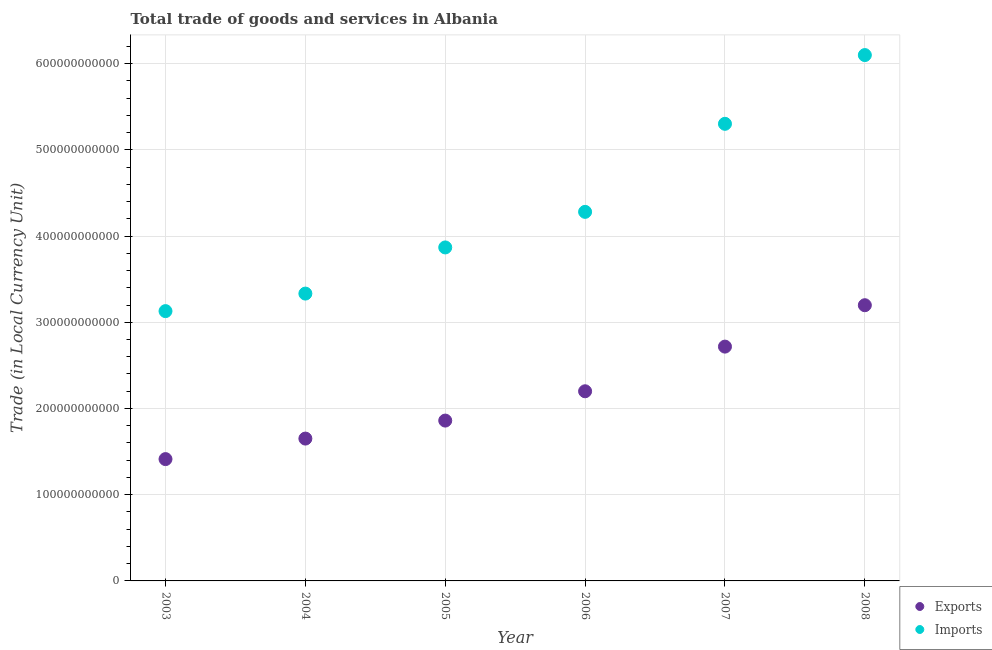How many different coloured dotlines are there?
Ensure brevity in your answer.  2. What is the imports of goods and services in 2004?
Keep it short and to the point. 3.33e+11. Across all years, what is the maximum export of goods and services?
Give a very brief answer. 3.20e+11. Across all years, what is the minimum imports of goods and services?
Keep it short and to the point. 3.13e+11. What is the total imports of goods and services in the graph?
Give a very brief answer. 2.60e+12. What is the difference between the export of goods and services in 2004 and that in 2008?
Make the answer very short. -1.55e+11. What is the difference between the imports of goods and services in 2006 and the export of goods and services in 2004?
Ensure brevity in your answer.  2.63e+11. What is the average imports of goods and services per year?
Give a very brief answer. 4.34e+11. In the year 2003, what is the difference between the export of goods and services and imports of goods and services?
Make the answer very short. -1.72e+11. In how many years, is the export of goods and services greater than 240000000000 LCU?
Ensure brevity in your answer.  2. What is the ratio of the export of goods and services in 2005 to that in 2006?
Make the answer very short. 0.85. What is the difference between the highest and the second highest imports of goods and services?
Your answer should be compact. 7.97e+1. What is the difference between the highest and the lowest export of goods and services?
Make the answer very short. 1.78e+11. How many dotlines are there?
Give a very brief answer. 2. How many years are there in the graph?
Your response must be concise. 6. What is the difference between two consecutive major ticks on the Y-axis?
Keep it short and to the point. 1.00e+11. Does the graph contain grids?
Keep it short and to the point. Yes. Where does the legend appear in the graph?
Offer a terse response. Bottom right. What is the title of the graph?
Your answer should be very brief. Total trade of goods and services in Albania. Does "Malaria" appear as one of the legend labels in the graph?
Give a very brief answer. No. What is the label or title of the X-axis?
Ensure brevity in your answer.  Year. What is the label or title of the Y-axis?
Provide a short and direct response. Trade (in Local Currency Unit). What is the Trade (in Local Currency Unit) in Exports in 2003?
Provide a short and direct response. 1.41e+11. What is the Trade (in Local Currency Unit) in Imports in 2003?
Provide a succinct answer. 3.13e+11. What is the Trade (in Local Currency Unit) of Exports in 2004?
Your response must be concise. 1.65e+11. What is the Trade (in Local Currency Unit) in Imports in 2004?
Provide a succinct answer. 3.33e+11. What is the Trade (in Local Currency Unit) of Exports in 2005?
Give a very brief answer. 1.86e+11. What is the Trade (in Local Currency Unit) of Imports in 2005?
Offer a terse response. 3.87e+11. What is the Trade (in Local Currency Unit) in Exports in 2006?
Offer a very short reply. 2.20e+11. What is the Trade (in Local Currency Unit) of Imports in 2006?
Keep it short and to the point. 4.28e+11. What is the Trade (in Local Currency Unit) in Exports in 2007?
Ensure brevity in your answer.  2.72e+11. What is the Trade (in Local Currency Unit) in Imports in 2007?
Offer a very short reply. 5.30e+11. What is the Trade (in Local Currency Unit) in Exports in 2008?
Your answer should be very brief. 3.20e+11. What is the Trade (in Local Currency Unit) in Imports in 2008?
Provide a short and direct response. 6.10e+11. Across all years, what is the maximum Trade (in Local Currency Unit) in Exports?
Your answer should be compact. 3.20e+11. Across all years, what is the maximum Trade (in Local Currency Unit) of Imports?
Your response must be concise. 6.10e+11. Across all years, what is the minimum Trade (in Local Currency Unit) in Exports?
Provide a short and direct response. 1.41e+11. Across all years, what is the minimum Trade (in Local Currency Unit) of Imports?
Your response must be concise. 3.13e+11. What is the total Trade (in Local Currency Unit) of Exports in the graph?
Provide a short and direct response. 1.30e+12. What is the total Trade (in Local Currency Unit) in Imports in the graph?
Offer a terse response. 2.60e+12. What is the difference between the Trade (in Local Currency Unit) in Exports in 2003 and that in 2004?
Your response must be concise. -2.38e+1. What is the difference between the Trade (in Local Currency Unit) in Imports in 2003 and that in 2004?
Your answer should be compact. -2.03e+1. What is the difference between the Trade (in Local Currency Unit) of Exports in 2003 and that in 2005?
Ensure brevity in your answer.  -4.47e+1. What is the difference between the Trade (in Local Currency Unit) of Imports in 2003 and that in 2005?
Offer a terse response. -7.39e+1. What is the difference between the Trade (in Local Currency Unit) in Exports in 2003 and that in 2006?
Your response must be concise. -7.87e+1. What is the difference between the Trade (in Local Currency Unit) of Imports in 2003 and that in 2006?
Make the answer very short. -1.15e+11. What is the difference between the Trade (in Local Currency Unit) in Exports in 2003 and that in 2007?
Give a very brief answer. -1.30e+11. What is the difference between the Trade (in Local Currency Unit) of Imports in 2003 and that in 2007?
Keep it short and to the point. -2.17e+11. What is the difference between the Trade (in Local Currency Unit) in Exports in 2003 and that in 2008?
Ensure brevity in your answer.  -1.78e+11. What is the difference between the Trade (in Local Currency Unit) of Imports in 2003 and that in 2008?
Provide a short and direct response. -2.97e+11. What is the difference between the Trade (in Local Currency Unit) of Exports in 2004 and that in 2005?
Your answer should be compact. -2.09e+1. What is the difference between the Trade (in Local Currency Unit) of Imports in 2004 and that in 2005?
Your answer should be very brief. -5.35e+1. What is the difference between the Trade (in Local Currency Unit) of Exports in 2004 and that in 2006?
Make the answer very short. -5.49e+1. What is the difference between the Trade (in Local Currency Unit) in Imports in 2004 and that in 2006?
Make the answer very short. -9.48e+1. What is the difference between the Trade (in Local Currency Unit) in Exports in 2004 and that in 2007?
Give a very brief answer. -1.07e+11. What is the difference between the Trade (in Local Currency Unit) of Imports in 2004 and that in 2007?
Make the answer very short. -1.97e+11. What is the difference between the Trade (in Local Currency Unit) in Exports in 2004 and that in 2008?
Provide a succinct answer. -1.55e+11. What is the difference between the Trade (in Local Currency Unit) of Imports in 2004 and that in 2008?
Keep it short and to the point. -2.77e+11. What is the difference between the Trade (in Local Currency Unit) in Exports in 2005 and that in 2006?
Give a very brief answer. -3.40e+1. What is the difference between the Trade (in Local Currency Unit) in Imports in 2005 and that in 2006?
Give a very brief answer. -4.13e+1. What is the difference between the Trade (in Local Currency Unit) in Exports in 2005 and that in 2007?
Your response must be concise. -8.58e+1. What is the difference between the Trade (in Local Currency Unit) in Imports in 2005 and that in 2007?
Keep it short and to the point. -1.43e+11. What is the difference between the Trade (in Local Currency Unit) in Exports in 2005 and that in 2008?
Your answer should be very brief. -1.34e+11. What is the difference between the Trade (in Local Currency Unit) in Imports in 2005 and that in 2008?
Make the answer very short. -2.23e+11. What is the difference between the Trade (in Local Currency Unit) of Exports in 2006 and that in 2007?
Offer a terse response. -5.18e+1. What is the difference between the Trade (in Local Currency Unit) in Imports in 2006 and that in 2007?
Provide a short and direct response. -1.02e+11. What is the difference between the Trade (in Local Currency Unit) in Exports in 2006 and that in 2008?
Ensure brevity in your answer.  -9.98e+1. What is the difference between the Trade (in Local Currency Unit) in Imports in 2006 and that in 2008?
Ensure brevity in your answer.  -1.82e+11. What is the difference between the Trade (in Local Currency Unit) in Exports in 2007 and that in 2008?
Provide a succinct answer. -4.80e+1. What is the difference between the Trade (in Local Currency Unit) of Imports in 2007 and that in 2008?
Make the answer very short. -7.97e+1. What is the difference between the Trade (in Local Currency Unit) of Exports in 2003 and the Trade (in Local Currency Unit) of Imports in 2004?
Make the answer very short. -1.92e+11. What is the difference between the Trade (in Local Currency Unit) in Exports in 2003 and the Trade (in Local Currency Unit) in Imports in 2005?
Make the answer very short. -2.46e+11. What is the difference between the Trade (in Local Currency Unit) of Exports in 2003 and the Trade (in Local Currency Unit) of Imports in 2006?
Provide a short and direct response. -2.87e+11. What is the difference between the Trade (in Local Currency Unit) in Exports in 2003 and the Trade (in Local Currency Unit) in Imports in 2007?
Keep it short and to the point. -3.89e+11. What is the difference between the Trade (in Local Currency Unit) of Exports in 2003 and the Trade (in Local Currency Unit) of Imports in 2008?
Make the answer very short. -4.69e+11. What is the difference between the Trade (in Local Currency Unit) in Exports in 2004 and the Trade (in Local Currency Unit) in Imports in 2005?
Give a very brief answer. -2.22e+11. What is the difference between the Trade (in Local Currency Unit) of Exports in 2004 and the Trade (in Local Currency Unit) of Imports in 2006?
Ensure brevity in your answer.  -2.63e+11. What is the difference between the Trade (in Local Currency Unit) of Exports in 2004 and the Trade (in Local Currency Unit) of Imports in 2007?
Your answer should be very brief. -3.65e+11. What is the difference between the Trade (in Local Currency Unit) of Exports in 2004 and the Trade (in Local Currency Unit) of Imports in 2008?
Your response must be concise. -4.45e+11. What is the difference between the Trade (in Local Currency Unit) of Exports in 2005 and the Trade (in Local Currency Unit) of Imports in 2006?
Your answer should be very brief. -2.42e+11. What is the difference between the Trade (in Local Currency Unit) in Exports in 2005 and the Trade (in Local Currency Unit) in Imports in 2007?
Make the answer very short. -3.44e+11. What is the difference between the Trade (in Local Currency Unit) of Exports in 2005 and the Trade (in Local Currency Unit) of Imports in 2008?
Offer a very short reply. -4.24e+11. What is the difference between the Trade (in Local Currency Unit) in Exports in 2006 and the Trade (in Local Currency Unit) in Imports in 2007?
Your answer should be compact. -3.10e+11. What is the difference between the Trade (in Local Currency Unit) of Exports in 2006 and the Trade (in Local Currency Unit) of Imports in 2008?
Offer a terse response. -3.90e+11. What is the difference between the Trade (in Local Currency Unit) in Exports in 2007 and the Trade (in Local Currency Unit) in Imports in 2008?
Your answer should be very brief. -3.38e+11. What is the average Trade (in Local Currency Unit) of Exports per year?
Provide a short and direct response. 2.17e+11. What is the average Trade (in Local Currency Unit) of Imports per year?
Offer a terse response. 4.34e+11. In the year 2003, what is the difference between the Trade (in Local Currency Unit) of Exports and Trade (in Local Currency Unit) of Imports?
Keep it short and to the point. -1.72e+11. In the year 2004, what is the difference between the Trade (in Local Currency Unit) of Exports and Trade (in Local Currency Unit) of Imports?
Ensure brevity in your answer.  -1.68e+11. In the year 2005, what is the difference between the Trade (in Local Currency Unit) in Exports and Trade (in Local Currency Unit) in Imports?
Provide a short and direct response. -2.01e+11. In the year 2006, what is the difference between the Trade (in Local Currency Unit) in Exports and Trade (in Local Currency Unit) in Imports?
Provide a succinct answer. -2.08e+11. In the year 2007, what is the difference between the Trade (in Local Currency Unit) of Exports and Trade (in Local Currency Unit) of Imports?
Make the answer very short. -2.58e+11. In the year 2008, what is the difference between the Trade (in Local Currency Unit) of Exports and Trade (in Local Currency Unit) of Imports?
Offer a terse response. -2.90e+11. What is the ratio of the Trade (in Local Currency Unit) of Exports in 2003 to that in 2004?
Keep it short and to the point. 0.86. What is the ratio of the Trade (in Local Currency Unit) in Imports in 2003 to that in 2004?
Your answer should be compact. 0.94. What is the ratio of the Trade (in Local Currency Unit) of Exports in 2003 to that in 2005?
Provide a succinct answer. 0.76. What is the ratio of the Trade (in Local Currency Unit) in Imports in 2003 to that in 2005?
Provide a short and direct response. 0.81. What is the ratio of the Trade (in Local Currency Unit) in Exports in 2003 to that in 2006?
Offer a terse response. 0.64. What is the ratio of the Trade (in Local Currency Unit) of Imports in 2003 to that in 2006?
Keep it short and to the point. 0.73. What is the ratio of the Trade (in Local Currency Unit) in Exports in 2003 to that in 2007?
Offer a terse response. 0.52. What is the ratio of the Trade (in Local Currency Unit) in Imports in 2003 to that in 2007?
Your answer should be very brief. 0.59. What is the ratio of the Trade (in Local Currency Unit) in Exports in 2003 to that in 2008?
Offer a very short reply. 0.44. What is the ratio of the Trade (in Local Currency Unit) of Imports in 2003 to that in 2008?
Your response must be concise. 0.51. What is the ratio of the Trade (in Local Currency Unit) in Exports in 2004 to that in 2005?
Make the answer very short. 0.89. What is the ratio of the Trade (in Local Currency Unit) of Imports in 2004 to that in 2005?
Provide a succinct answer. 0.86. What is the ratio of the Trade (in Local Currency Unit) in Exports in 2004 to that in 2006?
Offer a terse response. 0.75. What is the ratio of the Trade (in Local Currency Unit) of Imports in 2004 to that in 2006?
Your answer should be compact. 0.78. What is the ratio of the Trade (in Local Currency Unit) in Exports in 2004 to that in 2007?
Your response must be concise. 0.61. What is the ratio of the Trade (in Local Currency Unit) of Imports in 2004 to that in 2007?
Your answer should be very brief. 0.63. What is the ratio of the Trade (in Local Currency Unit) of Exports in 2004 to that in 2008?
Offer a terse response. 0.52. What is the ratio of the Trade (in Local Currency Unit) of Imports in 2004 to that in 2008?
Give a very brief answer. 0.55. What is the ratio of the Trade (in Local Currency Unit) of Exports in 2005 to that in 2006?
Your answer should be very brief. 0.85. What is the ratio of the Trade (in Local Currency Unit) of Imports in 2005 to that in 2006?
Provide a short and direct response. 0.9. What is the ratio of the Trade (in Local Currency Unit) of Exports in 2005 to that in 2007?
Offer a terse response. 0.68. What is the ratio of the Trade (in Local Currency Unit) of Imports in 2005 to that in 2007?
Your answer should be compact. 0.73. What is the ratio of the Trade (in Local Currency Unit) of Exports in 2005 to that in 2008?
Your answer should be compact. 0.58. What is the ratio of the Trade (in Local Currency Unit) in Imports in 2005 to that in 2008?
Your answer should be compact. 0.63. What is the ratio of the Trade (in Local Currency Unit) in Exports in 2006 to that in 2007?
Offer a very short reply. 0.81. What is the ratio of the Trade (in Local Currency Unit) of Imports in 2006 to that in 2007?
Offer a terse response. 0.81. What is the ratio of the Trade (in Local Currency Unit) in Exports in 2006 to that in 2008?
Ensure brevity in your answer.  0.69. What is the ratio of the Trade (in Local Currency Unit) in Imports in 2006 to that in 2008?
Your answer should be compact. 0.7. What is the ratio of the Trade (in Local Currency Unit) of Exports in 2007 to that in 2008?
Your answer should be compact. 0.85. What is the ratio of the Trade (in Local Currency Unit) of Imports in 2007 to that in 2008?
Your response must be concise. 0.87. What is the difference between the highest and the second highest Trade (in Local Currency Unit) of Exports?
Offer a terse response. 4.80e+1. What is the difference between the highest and the second highest Trade (in Local Currency Unit) in Imports?
Give a very brief answer. 7.97e+1. What is the difference between the highest and the lowest Trade (in Local Currency Unit) in Exports?
Your response must be concise. 1.78e+11. What is the difference between the highest and the lowest Trade (in Local Currency Unit) in Imports?
Your response must be concise. 2.97e+11. 